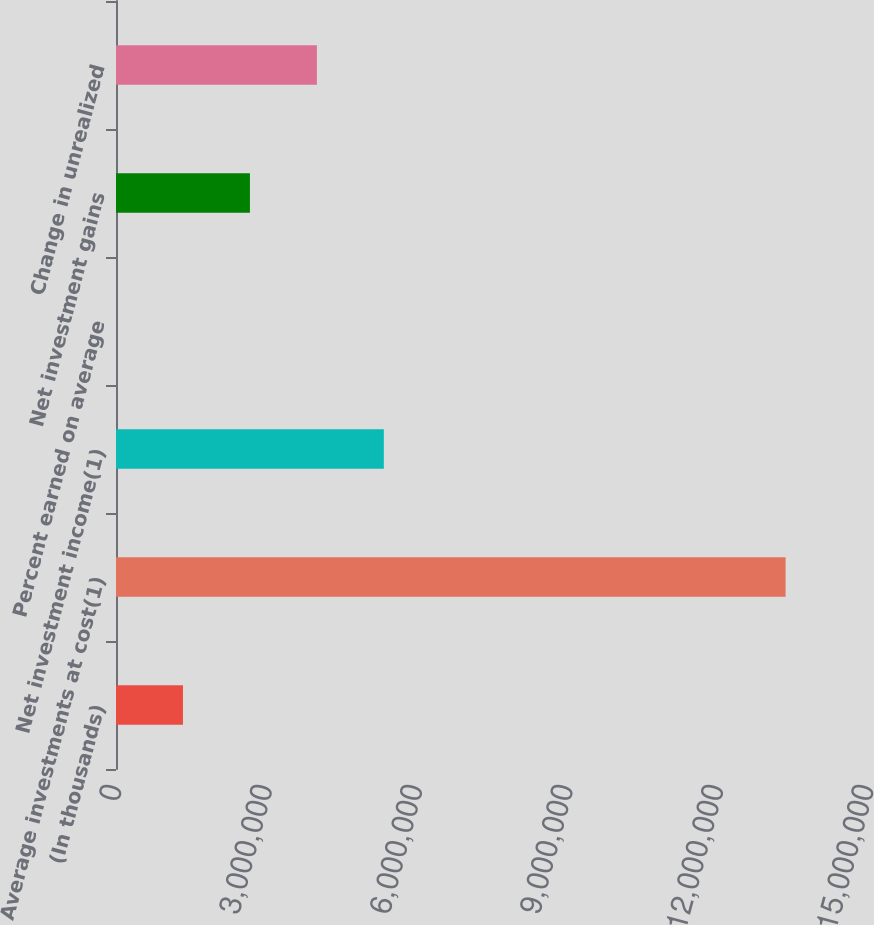Convert chart. <chart><loc_0><loc_0><loc_500><loc_500><bar_chart><fcel>(In thousands)<fcel>Average investments at cost(1)<fcel>Net investment income(1)<fcel>Percent earned on average<fcel>Net investment gains<fcel>Change in unrealized<nl><fcel>1.33564e+06<fcel>1.33564e+07<fcel>5.34255e+06<fcel>4<fcel>2.67128e+06<fcel>4.00692e+06<nl></chart> 